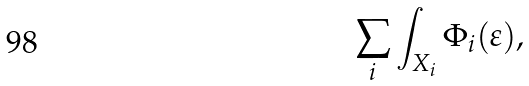Convert formula to latex. <formula><loc_0><loc_0><loc_500><loc_500>\sum _ { i } \int _ { X _ { i } } \Phi _ { i } ( \varepsilon ) ,</formula> 